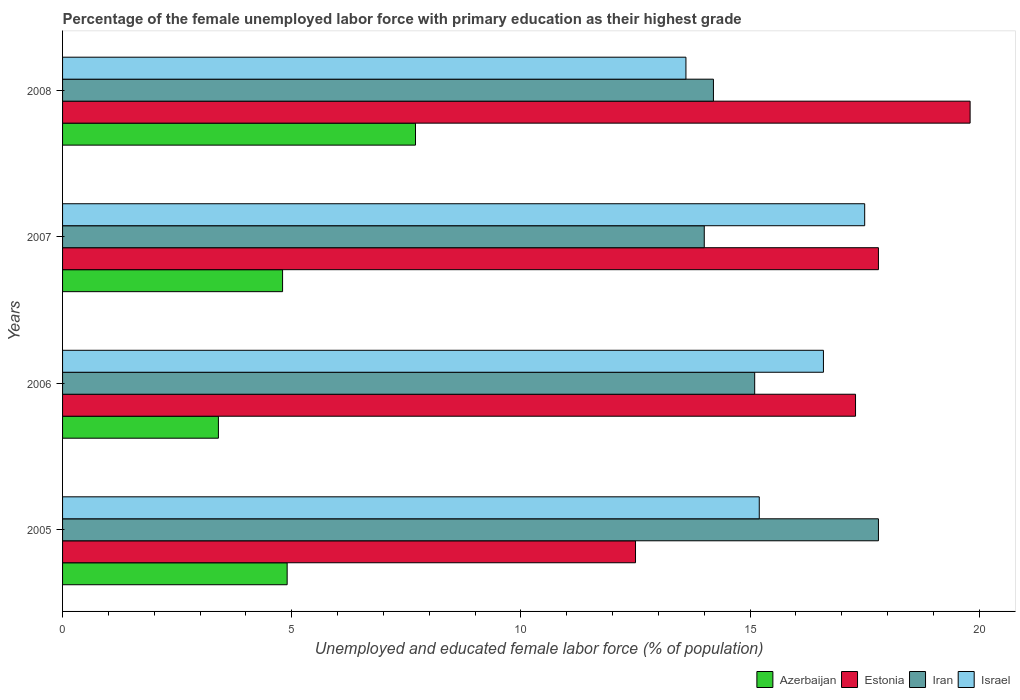How many different coloured bars are there?
Give a very brief answer. 4. Are the number of bars per tick equal to the number of legend labels?
Give a very brief answer. Yes. How many bars are there on the 1st tick from the bottom?
Offer a very short reply. 4. In how many cases, is the number of bars for a given year not equal to the number of legend labels?
Your answer should be compact. 0. What is the percentage of the unemployed female labor force with primary education in Iran in 2008?
Ensure brevity in your answer.  14.2. Across all years, what is the maximum percentage of the unemployed female labor force with primary education in Israel?
Offer a terse response. 17.5. Across all years, what is the minimum percentage of the unemployed female labor force with primary education in Azerbaijan?
Provide a short and direct response. 3.4. In which year was the percentage of the unemployed female labor force with primary education in Azerbaijan maximum?
Your answer should be very brief. 2008. What is the total percentage of the unemployed female labor force with primary education in Israel in the graph?
Provide a short and direct response. 62.9. What is the difference between the percentage of the unemployed female labor force with primary education in Iran in 2006 and that in 2007?
Give a very brief answer. 1.1. What is the average percentage of the unemployed female labor force with primary education in Azerbaijan per year?
Ensure brevity in your answer.  5.2. In the year 2005, what is the difference between the percentage of the unemployed female labor force with primary education in Azerbaijan and percentage of the unemployed female labor force with primary education in Iran?
Offer a terse response. -12.9. What is the ratio of the percentage of the unemployed female labor force with primary education in Iran in 2007 to that in 2008?
Ensure brevity in your answer.  0.99. What is the difference between the highest and the second highest percentage of the unemployed female labor force with primary education in Iran?
Make the answer very short. 2.7. What is the difference between the highest and the lowest percentage of the unemployed female labor force with primary education in Azerbaijan?
Offer a very short reply. 4.3. In how many years, is the percentage of the unemployed female labor force with primary education in Israel greater than the average percentage of the unemployed female labor force with primary education in Israel taken over all years?
Make the answer very short. 2. What does the 1st bar from the bottom in 2005 represents?
Give a very brief answer. Azerbaijan. What is the difference between two consecutive major ticks on the X-axis?
Your answer should be very brief. 5. How many legend labels are there?
Give a very brief answer. 4. How are the legend labels stacked?
Give a very brief answer. Horizontal. What is the title of the graph?
Offer a very short reply. Percentage of the female unemployed labor force with primary education as their highest grade. Does "Iceland" appear as one of the legend labels in the graph?
Offer a terse response. No. What is the label or title of the X-axis?
Your answer should be compact. Unemployed and educated female labor force (% of population). What is the label or title of the Y-axis?
Make the answer very short. Years. What is the Unemployed and educated female labor force (% of population) in Azerbaijan in 2005?
Give a very brief answer. 4.9. What is the Unemployed and educated female labor force (% of population) in Estonia in 2005?
Give a very brief answer. 12.5. What is the Unemployed and educated female labor force (% of population) of Iran in 2005?
Your response must be concise. 17.8. What is the Unemployed and educated female labor force (% of population) in Israel in 2005?
Your response must be concise. 15.2. What is the Unemployed and educated female labor force (% of population) in Azerbaijan in 2006?
Your response must be concise. 3.4. What is the Unemployed and educated female labor force (% of population) of Estonia in 2006?
Give a very brief answer. 17.3. What is the Unemployed and educated female labor force (% of population) of Iran in 2006?
Keep it short and to the point. 15.1. What is the Unemployed and educated female labor force (% of population) of Israel in 2006?
Keep it short and to the point. 16.6. What is the Unemployed and educated female labor force (% of population) in Azerbaijan in 2007?
Provide a short and direct response. 4.8. What is the Unemployed and educated female labor force (% of population) of Estonia in 2007?
Your answer should be very brief. 17.8. What is the Unemployed and educated female labor force (% of population) in Israel in 2007?
Provide a short and direct response. 17.5. What is the Unemployed and educated female labor force (% of population) of Azerbaijan in 2008?
Provide a succinct answer. 7.7. What is the Unemployed and educated female labor force (% of population) in Estonia in 2008?
Ensure brevity in your answer.  19.8. What is the Unemployed and educated female labor force (% of population) of Iran in 2008?
Provide a short and direct response. 14.2. What is the Unemployed and educated female labor force (% of population) of Israel in 2008?
Your response must be concise. 13.6. Across all years, what is the maximum Unemployed and educated female labor force (% of population) in Azerbaijan?
Make the answer very short. 7.7. Across all years, what is the maximum Unemployed and educated female labor force (% of population) in Estonia?
Keep it short and to the point. 19.8. Across all years, what is the maximum Unemployed and educated female labor force (% of population) in Iran?
Provide a short and direct response. 17.8. Across all years, what is the minimum Unemployed and educated female labor force (% of population) in Azerbaijan?
Give a very brief answer. 3.4. Across all years, what is the minimum Unemployed and educated female labor force (% of population) of Estonia?
Give a very brief answer. 12.5. Across all years, what is the minimum Unemployed and educated female labor force (% of population) in Iran?
Keep it short and to the point. 14. Across all years, what is the minimum Unemployed and educated female labor force (% of population) of Israel?
Keep it short and to the point. 13.6. What is the total Unemployed and educated female labor force (% of population) of Azerbaijan in the graph?
Offer a very short reply. 20.8. What is the total Unemployed and educated female labor force (% of population) of Estonia in the graph?
Make the answer very short. 67.4. What is the total Unemployed and educated female labor force (% of population) in Iran in the graph?
Make the answer very short. 61.1. What is the total Unemployed and educated female labor force (% of population) in Israel in the graph?
Offer a terse response. 62.9. What is the difference between the Unemployed and educated female labor force (% of population) in Estonia in 2005 and that in 2006?
Your answer should be very brief. -4.8. What is the difference between the Unemployed and educated female labor force (% of population) of Iran in 2005 and that in 2006?
Offer a very short reply. 2.7. What is the difference between the Unemployed and educated female labor force (% of population) in Israel in 2005 and that in 2006?
Make the answer very short. -1.4. What is the difference between the Unemployed and educated female labor force (% of population) in Israel in 2005 and that in 2007?
Your response must be concise. -2.3. What is the difference between the Unemployed and educated female labor force (% of population) of Estonia in 2005 and that in 2008?
Provide a succinct answer. -7.3. What is the difference between the Unemployed and educated female labor force (% of population) of Estonia in 2006 and that in 2007?
Offer a terse response. -0.5. What is the difference between the Unemployed and educated female labor force (% of population) in Iran in 2006 and that in 2007?
Your answer should be very brief. 1.1. What is the difference between the Unemployed and educated female labor force (% of population) of Israel in 2006 and that in 2007?
Offer a very short reply. -0.9. What is the difference between the Unemployed and educated female labor force (% of population) of Azerbaijan in 2006 and that in 2008?
Provide a short and direct response. -4.3. What is the difference between the Unemployed and educated female labor force (% of population) in Estonia in 2006 and that in 2008?
Offer a very short reply. -2.5. What is the difference between the Unemployed and educated female labor force (% of population) in Israel in 2006 and that in 2008?
Keep it short and to the point. 3. What is the difference between the Unemployed and educated female labor force (% of population) of Azerbaijan in 2007 and that in 2008?
Provide a succinct answer. -2.9. What is the difference between the Unemployed and educated female labor force (% of population) in Estonia in 2007 and that in 2008?
Offer a terse response. -2. What is the difference between the Unemployed and educated female labor force (% of population) of Azerbaijan in 2005 and the Unemployed and educated female labor force (% of population) of Estonia in 2006?
Offer a very short reply. -12.4. What is the difference between the Unemployed and educated female labor force (% of population) of Estonia in 2005 and the Unemployed and educated female labor force (% of population) of Iran in 2006?
Give a very brief answer. -2.6. What is the difference between the Unemployed and educated female labor force (% of population) of Estonia in 2005 and the Unemployed and educated female labor force (% of population) of Israel in 2006?
Offer a very short reply. -4.1. What is the difference between the Unemployed and educated female labor force (% of population) of Iran in 2005 and the Unemployed and educated female labor force (% of population) of Israel in 2006?
Give a very brief answer. 1.2. What is the difference between the Unemployed and educated female labor force (% of population) of Azerbaijan in 2005 and the Unemployed and educated female labor force (% of population) of Israel in 2007?
Your answer should be very brief. -12.6. What is the difference between the Unemployed and educated female labor force (% of population) in Estonia in 2005 and the Unemployed and educated female labor force (% of population) in Israel in 2007?
Your answer should be compact. -5. What is the difference between the Unemployed and educated female labor force (% of population) in Iran in 2005 and the Unemployed and educated female labor force (% of population) in Israel in 2007?
Offer a terse response. 0.3. What is the difference between the Unemployed and educated female labor force (% of population) in Azerbaijan in 2005 and the Unemployed and educated female labor force (% of population) in Estonia in 2008?
Provide a succinct answer. -14.9. What is the difference between the Unemployed and educated female labor force (% of population) of Estonia in 2005 and the Unemployed and educated female labor force (% of population) of Iran in 2008?
Give a very brief answer. -1.7. What is the difference between the Unemployed and educated female labor force (% of population) of Estonia in 2005 and the Unemployed and educated female labor force (% of population) of Israel in 2008?
Make the answer very short. -1.1. What is the difference between the Unemployed and educated female labor force (% of population) of Iran in 2005 and the Unemployed and educated female labor force (% of population) of Israel in 2008?
Your answer should be compact. 4.2. What is the difference between the Unemployed and educated female labor force (% of population) in Azerbaijan in 2006 and the Unemployed and educated female labor force (% of population) in Estonia in 2007?
Offer a terse response. -14.4. What is the difference between the Unemployed and educated female labor force (% of population) of Azerbaijan in 2006 and the Unemployed and educated female labor force (% of population) of Iran in 2007?
Offer a very short reply. -10.6. What is the difference between the Unemployed and educated female labor force (% of population) of Azerbaijan in 2006 and the Unemployed and educated female labor force (% of population) of Israel in 2007?
Keep it short and to the point. -14.1. What is the difference between the Unemployed and educated female labor force (% of population) of Iran in 2006 and the Unemployed and educated female labor force (% of population) of Israel in 2007?
Provide a succinct answer. -2.4. What is the difference between the Unemployed and educated female labor force (% of population) of Azerbaijan in 2006 and the Unemployed and educated female labor force (% of population) of Estonia in 2008?
Provide a short and direct response. -16.4. What is the difference between the Unemployed and educated female labor force (% of population) in Azerbaijan in 2006 and the Unemployed and educated female labor force (% of population) in Iran in 2008?
Provide a succinct answer. -10.8. What is the difference between the Unemployed and educated female labor force (% of population) of Azerbaijan in 2006 and the Unemployed and educated female labor force (% of population) of Israel in 2008?
Ensure brevity in your answer.  -10.2. What is the difference between the Unemployed and educated female labor force (% of population) in Estonia in 2006 and the Unemployed and educated female labor force (% of population) in Iran in 2008?
Offer a very short reply. 3.1. What is the difference between the Unemployed and educated female labor force (% of population) of Iran in 2006 and the Unemployed and educated female labor force (% of population) of Israel in 2008?
Provide a succinct answer. 1.5. What is the difference between the Unemployed and educated female labor force (% of population) in Azerbaijan in 2007 and the Unemployed and educated female labor force (% of population) in Estonia in 2008?
Your response must be concise. -15. What is the difference between the Unemployed and educated female labor force (% of population) in Iran in 2007 and the Unemployed and educated female labor force (% of population) in Israel in 2008?
Offer a terse response. 0.4. What is the average Unemployed and educated female labor force (% of population) in Estonia per year?
Ensure brevity in your answer.  16.85. What is the average Unemployed and educated female labor force (% of population) of Iran per year?
Your answer should be compact. 15.28. What is the average Unemployed and educated female labor force (% of population) of Israel per year?
Your answer should be compact. 15.72. In the year 2005, what is the difference between the Unemployed and educated female labor force (% of population) in Azerbaijan and Unemployed and educated female labor force (% of population) in Israel?
Your answer should be compact. -10.3. In the year 2005, what is the difference between the Unemployed and educated female labor force (% of population) in Estonia and Unemployed and educated female labor force (% of population) in Israel?
Keep it short and to the point. -2.7. In the year 2005, what is the difference between the Unemployed and educated female labor force (% of population) in Iran and Unemployed and educated female labor force (% of population) in Israel?
Offer a very short reply. 2.6. In the year 2006, what is the difference between the Unemployed and educated female labor force (% of population) of Azerbaijan and Unemployed and educated female labor force (% of population) of Iran?
Your answer should be compact. -11.7. In the year 2006, what is the difference between the Unemployed and educated female labor force (% of population) of Azerbaijan and Unemployed and educated female labor force (% of population) of Israel?
Your response must be concise. -13.2. In the year 2006, what is the difference between the Unemployed and educated female labor force (% of population) in Estonia and Unemployed and educated female labor force (% of population) in Iran?
Offer a very short reply. 2.2. In the year 2006, what is the difference between the Unemployed and educated female labor force (% of population) in Iran and Unemployed and educated female labor force (% of population) in Israel?
Make the answer very short. -1.5. In the year 2007, what is the difference between the Unemployed and educated female labor force (% of population) in Azerbaijan and Unemployed and educated female labor force (% of population) in Iran?
Give a very brief answer. -9.2. In the year 2007, what is the difference between the Unemployed and educated female labor force (% of population) in Azerbaijan and Unemployed and educated female labor force (% of population) in Israel?
Your answer should be compact. -12.7. In the year 2007, what is the difference between the Unemployed and educated female labor force (% of population) in Iran and Unemployed and educated female labor force (% of population) in Israel?
Give a very brief answer. -3.5. In the year 2008, what is the difference between the Unemployed and educated female labor force (% of population) of Azerbaijan and Unemployed and educated female labor force (% of population) of Estonia?
Your answer should be compact. -12.1. In the year 2008, what is the difference between the Unemployed and educated female labor force (% of population) of Estonia and Unemployed and educated female labor force (% of population) of Iran?
Your answer should be compact. 5.6. In the year 2008, what is the difference between the Unemployed and educated female labor force (% of population) of Estonia and Unemployed and educated female labor force (% of population) of Israel?
Your response must be concise. 6.2. What is the ratio of the Unemployed and educated female labor force (% of population) of Azerbaijan in 2005 to that in 2006?
Your answer should be very brief. 1.44. What is the ratio of the Unemployed and educated female labor force (% of population) in Estonia in 2005 to that in 2006?
Offer a very short reply. 0.72. What is the ratio of the Unemployed and educated female labor force (% of population) of Iran in 2005 to that in 2006?
Make the answer very short. 1.18. What is the ratio of the Unemployed and educated female labor force (% of population) of Israel in 2005 to that in 2006?
Provide a short and direct response. 0.92. What is the ratio of the Unemployed and educated female labor force (% of population) of Azerbaijan in 2005 to that in 2007?
Provide a short and direct response. 1.02. What is the ratio of the Unemployed and educated female labor force (% of population) in Estonia in 2005 to that in 2007?
Your answer should be compact. 0.7. What is the ratio of the Unemployed and educated female labor force (% of population) in Iran in 2005 to that in 2007?
Your answer should be very brief. 1.27. What is the ratio of the Unemployed and educated female labor force (% of population) in Israel in 2005 to that in 2007?
Give a very brief answer. 0.87. What is the ratio of the Unemployed and educated female labor force (% of population) in Azerbaijan in 2005 to that in 2008?
Your response must be concise. 0.64. What is the ratio of the Unemployed and educated female labor force (% of population) of Estonia in 2005 to that in 2008?
Ensure brevity in your answer.  0.63. What is the ratio of the Unemployed and educated female labor force (% of population) in Iran in 2005 to that in 2008?
Keep it short and to the point. 1.25. What is the ratio of the Unemployed and educated female labor force (% of population) of Israel in 2005 to that in 2008?
Give a very brief answer. 1.12. What is the ratio of the Unemployed and educated female labor force (% of population) of Azerbaijan in 2006 to that in 2007?
Make the answer very short. 0.71. What is the ratio of the Unemployed and educated female labor force (% of population) of Estonia in 2006 to that in 2007?
Ensure brevity in your answer.  0.97. What is the ratio of the Unemployed and educated female labor force (% of population) of Iran in 2006 to that in 2007?
Provide a succinct answer. 1.08. What is the ratio of the Unemployed and educated female labor force (% of population) in Israel in 2006 to that in 2007?
Your answer should be compact. 0.95. What is the ratio of the Unemployed and educated female labor force (% of population) of Azerbaijan in 2006 to that in 2008?
Your answer should be compact. 0.44. What is the ratio of the Unemployed and educated female labor force (% of population) in Estonia in 2006 to that in 2008?
Make the answer very short. 0.87. What is the ratio of the Unemployed and educated female labor force (% of population) in Iran in 2006 to that in 2008?
Your answer should be compact. 1.06. What is the ratio of the Unemployed and educated female labor force (% of population) in Israel in 2006 to that in 2008?
Your response must be concise. 1.22. What is the ratio of the Unemployed and educated female labor force (% of population) in Azerbaijan in 2007 to that in 2008?
Offer a very short reply. 0.62. What is the ratio of the Unemployed and educated female labor force (% of population) of Estonia in 2007 to that in 2008?
Provide a short and direct response. 0.9. What is the ratio of the Unemployed and educated female labor force (% of population) in Iran in 2007 to that in 2008?
Make the answer very short. 0.99. What is the ratio of the Unemployed and educated female labor force (% of population) in Israel in 2007 to that in 2008?
Provide a short and direct response. 1.29. What is the difference between the highest and the second highest Unemployed and educated female labor force (% of population) of Estonia?
Give a very brief answer. 2. What is the difference between the highest and the second highest Unemployed and educated female labor force (% of population) of Israel?
Your answer should be compact. 0.9. What is the difference between the highest and the lowest Unemployed and educated female labor force (% of population) of Estonia?
Your response must be concise. 7.3. What is the difference between the highest and the lowest Unemployed and educated female labor force (% of population) of Israel?
Keep it short and to the point. 3.9. 